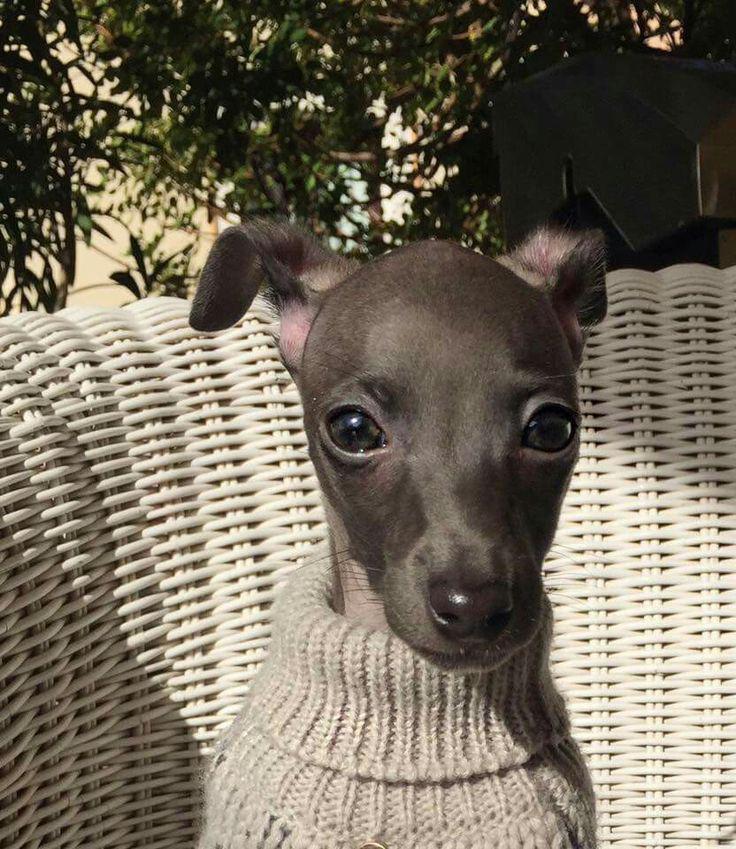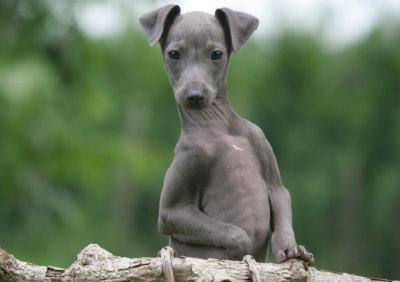The first image is the image on the left, the second image is the image on the right. Considering the images on both sides, is "An image shows a hound hugging a stuffed animal." valid? Answer yes or no. No. The first image is the image on the left, the second image is the image on the right. Analyze the images presented: Is the assertion "A dog in one image is cradling a stuffed animal toy while lying on a furry dark gray throw." valid? Answer yes or no. No. 